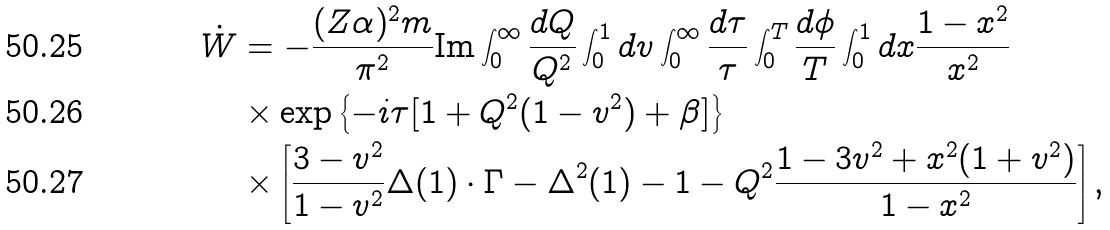Convert formula to latex. <formula><loc_0><loc_0><loc_500><loc_500>\dot { W } & = - \frac { ( Z \alpha ) ^ { 2 } m } { \pi ^ { 2 } } \text {Im} \int _ { 0 } ^ { \infty } \frac { d Q } { Q ^ { 2 } } \int _ { 0 } ^ { 1 } d v \int _ { 0 } ^ { \infty } \frac { d \tau } { \tau } \int _ { 0 } ^ { T } \frac { d \phi } { T } \int _ { 0 } ^ { 1 } d x \frac { 1 - x ^ { 2 } } { x ^ { 2 } } \\ & \times \exp \left \{ - i \tau [ 1 + Q ^ { 2 } ( 1 - v ^ { 2 } ) + \beta ] \right \} \\ & \times \left [ \frac { 3 - v ^ { 2 } } { 1 - v ^ { 2 } } \Delta ( 1 ) \cdot \Gamma - \Delta ^ { 2 } ( 1 ) - 1 - Q ^ { 2 } \frac { 1 - 3 v ^ { 2 } + x ^ { 2 } ( 1 + v ^ { 2 } ) } { 1 - x ^ { 2 } } \right ] ,</formula> 